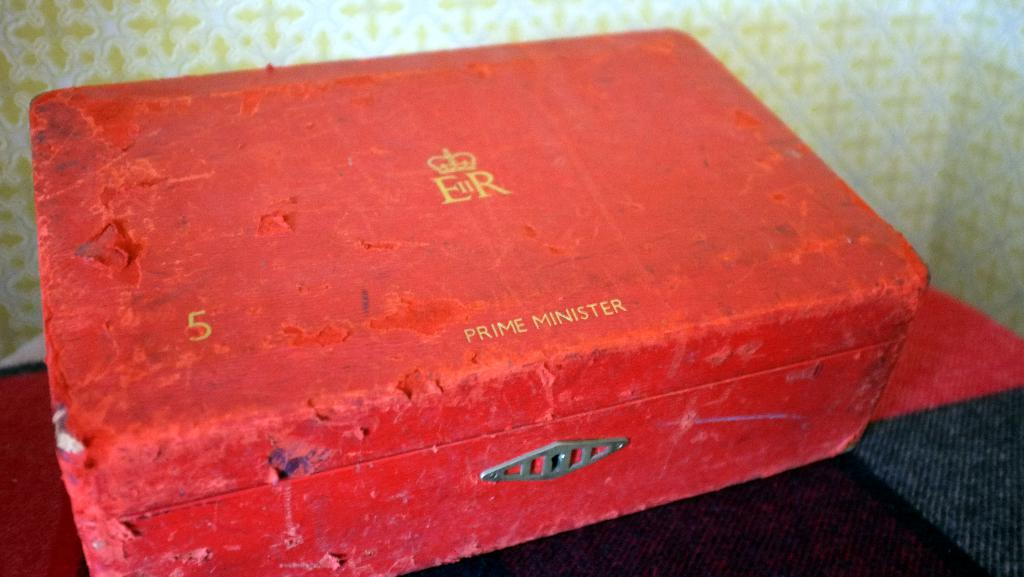<image>
Offer a succinct explanation of the picture presented. A red rectangular object with a writing that says Prime Minister. 